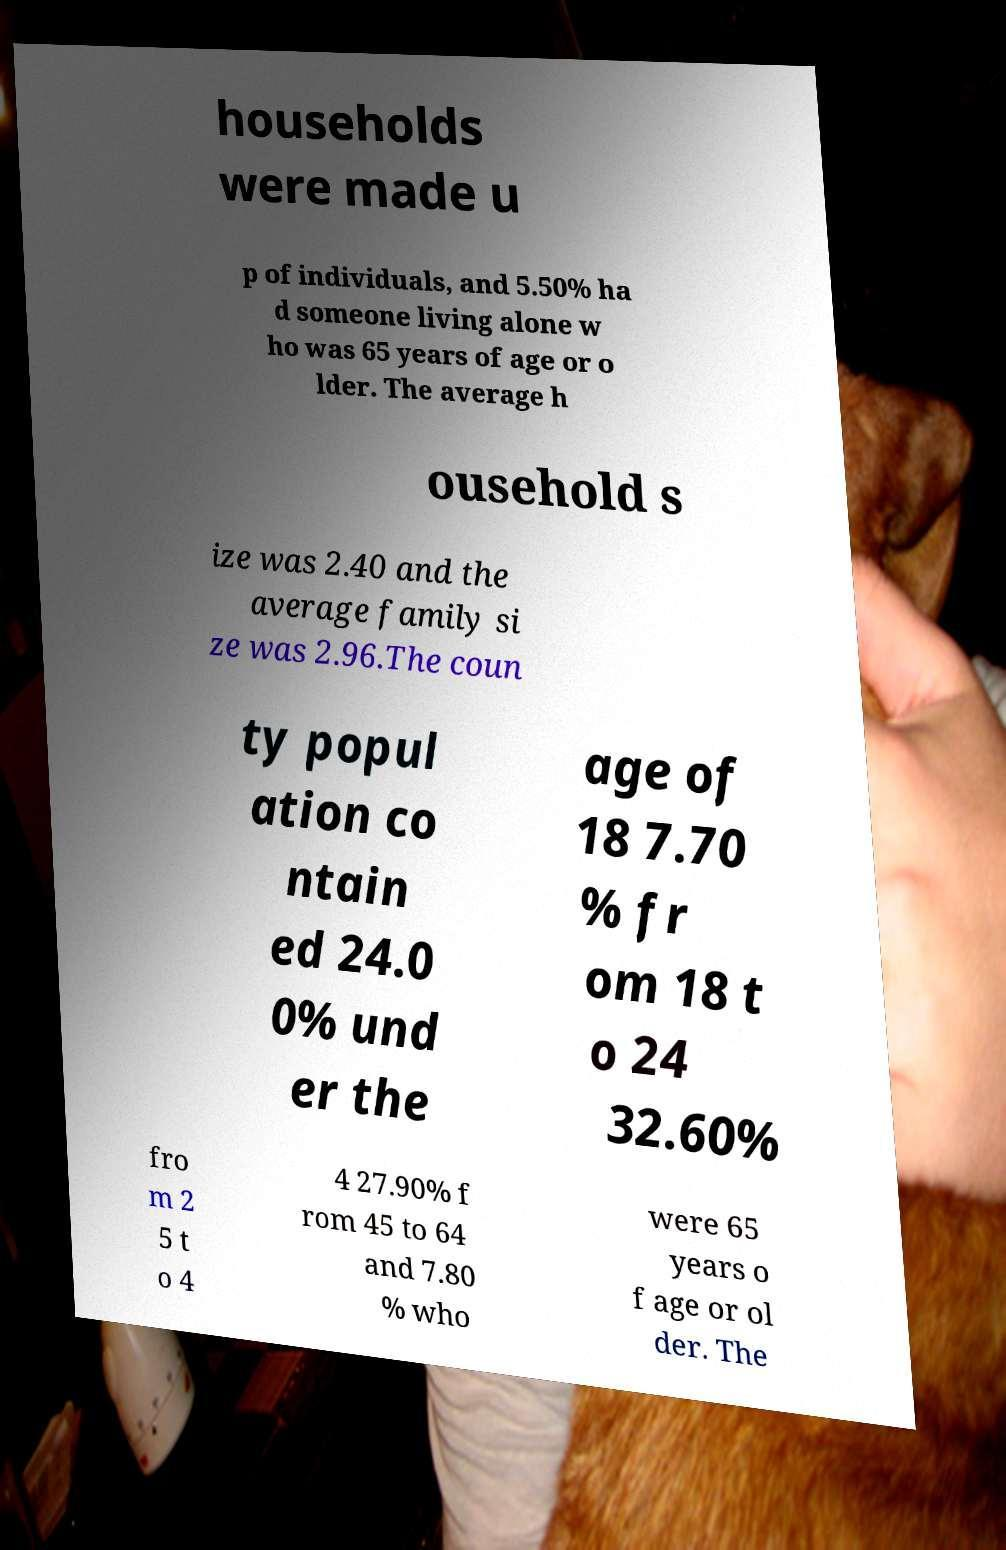Please identify and transcribe the text found in this image. households were made u p of individuals, and 5.50% ha d someone living alone w ho was 65 years of age or o lder. The average h ousehold s ize was 2.40 and the average family si ze was 2.96.The coun ty popul ation co ntain ed 24.0 0% und er the age of 18 7.70 % fr om 18 t o 24 32.60% fro m 2 5 t o 4 4 27.90% f rom 45 to 64 and 7.80 % who were 65 years o f age or ol der. The 